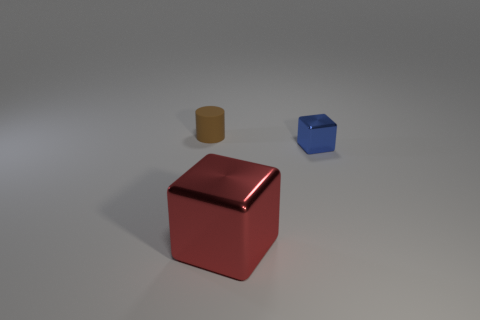Is the number of rubber objects behind the brown rubber thing greater than the number of tiny matte cylinders that are right of the tiny blue shiny object?
Provide a succinct answer. No. There is a small thing that is the same shape as the large red thing; what color is it?
Keep it short and to the point. Blue. There is a metallic thing that is right of the large red metal object; is its color the same as the cylinder?
Offer a very short reply. No. What number of tiny red rubber cylinders are there?
Ensure brevity in your answer.  0. Are the cube that is behind the big thing and the brown cylinder made of the same material?
Provide a succinct answer. No. Is there anything else that is the same material as the large red cube?
Your answer should be compact. Yes. There is a block that is in front of the tiny thing to the right of the red metal cube; how many matte cylinders are left of it?
Make the answer very short. 1. What is the size of the brown thing?
Your response must be concise. Small. Is the cylinder the same color as the small metal block?
Provide a succinct answer. No. There is a object that is right of the large metallic object; how big is it?
Keep it short and to the point. Small. 